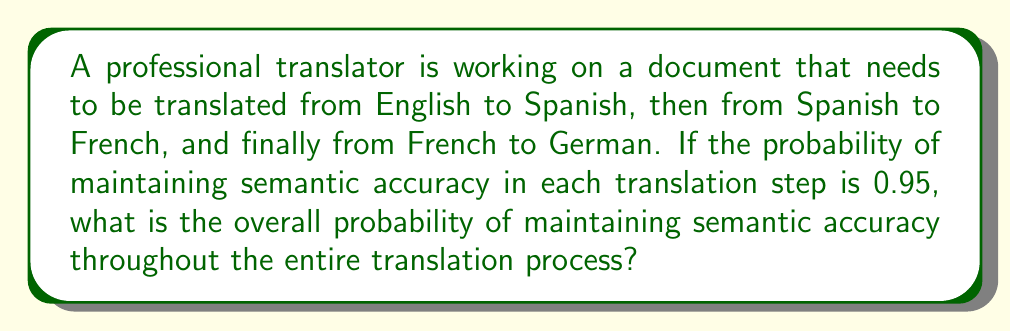Solve this math problem. Let's approach this step-by-step:

1) We need to maintain semantic accuracy in all three translation steps for the overall translation to be semantically accurate.

2) The probability of maintaining semantic accuracy in each step is 0.95.

3) To find the probability of all steps being accurate, we need to multiply the probabilities of each individual step being accurate.

4) This is because we're dealing with independent events, and the probability of all independent events occurring is the product of their individual probabilities.

5) Let's call the overall probability $P$:

   $$P = 0.95 \times 0.95 \times 0.95$$

6) We can simplify this:

   $$P = 0.95^3$$

7) Calculating this:

   $$P = 0.857375$$

8) Rounding to four decimal places:

   $$P \approx 0.8574$$

Therefore, the probability of maintaining semantic accuracy throughout the entire translation process is approximately 0.8574 or 85.74%.
Answer: 0.8574 